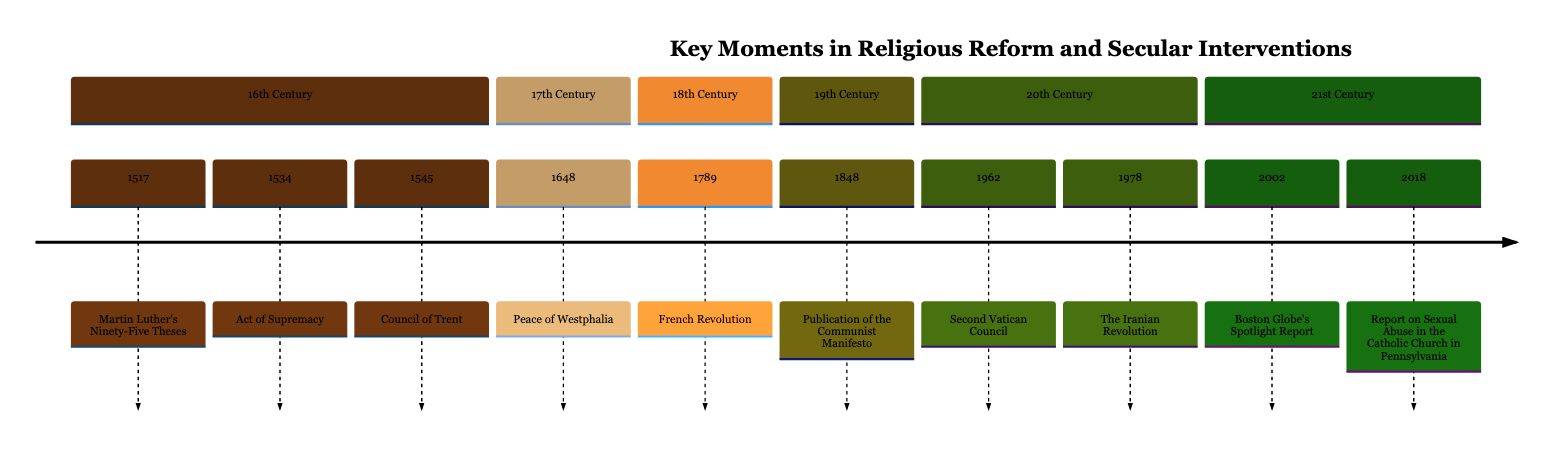What year did Martin Luther post his Ninety-Five Theses? The timeline shows Martin Luther's Ninety-Five Theses dated to the year 1517. This is a specific event in the 16th century section of the timeline.
Answer: 1517 What event follows the Act of Supremacy? The timeline lists the Act of Supremacy as occurring in 1534, followed directly by the Council of Trent in 1545. By referencing the order of events in the 16th century section, we can determine this relationship.
Answer: Council of Trent How many events are listed in the 20th century section? Looking at the timeline, the 20th century section includes three events: the Second Vatican Council in 1962, the Iranian Revolution in 1978, and the Boston Globe's Spotlight Report in 2002. This requires counting the events listed in that specific section.
Answer: 3 Which event is recognized for ending the Thirty Years' War? The Peace of Westphalia, dated 1648, in the 17th century section of the timeline, is noted as the event that officially ended the Thirty Years' War in Europe. This requires recalling details associated with the specific event mentioned.
Answer: Peace of Westphalia What was the result of the French Revolution in relation to the Church? The timeline describes the French Revolution of 1789 as leading to the secularization and reduction of the Catholic Church's power in France. To answer, we combine the details from the event description of the timeline that specifies these outcomes.
Answer: Secularization What major publication criticized organized religion in 1848? The timeline indicates that the publication of the Communist Manifesto by Karl Marx and Friedrich Engels in 1848 criticized organized religion as an oppressive force. This requires recalling which event is specifically noted in this context.
Answer: Communist Manifesto What significant report was published in 2002 that involved the Catholic Church? The timeline states that the Boston Globe published a report in 2002 detailing widespread sexual abuse by Catholic priests in the U.S., which caused renewed calls for reform. The answer is directly linked to the description of this event.
Answer: Boston Globe's Spotlight Report In what year did the Second Vatican Council occur? The timeline clearly shows that the Second Vatican Council took place in 1962. This question tests the retrieval of information directly stated in the timeline without the need for deeper interpretation.
Answer: 1962 What was the effect of the grand jury report in Pennsylvania in 2018? The report on sexual abuse in the Catholic Church in Pennsylvania led to renewed calls for accountability and reform within the Catholic Church globally. This requires understanding the implications of the event detailed in the timeline.
Answer: Calls for accountability 